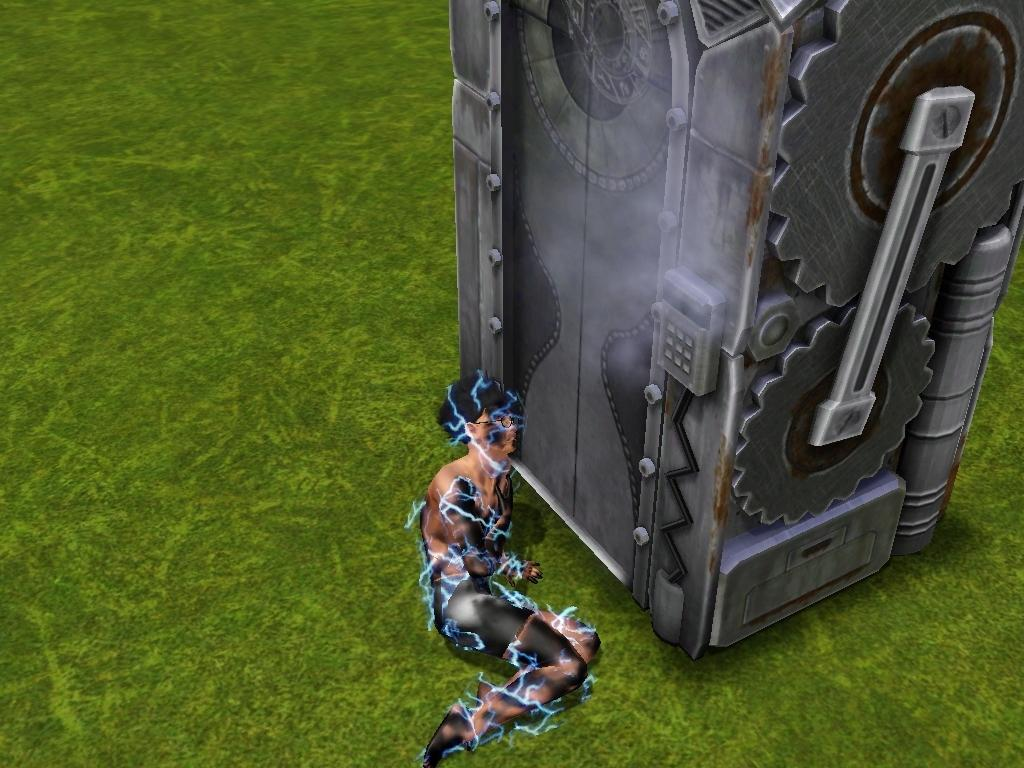What is the main subject of the animated picture in the image? The main subject of the animated picture is a grass surface. What else can be seen in the image besides the grass surface? There is machinery and a person in the image. What is the person doing in the image? The person is laying on the grass surface. How does the person appear in the image? The person appears to be in shock. What type of letters can be seen in the image? There are no letters present in the image. How does the society depicted in the image react to the person's shock? There is no society depicted in the image, as it is an animated picture of a grass surface with machinery and a person. 